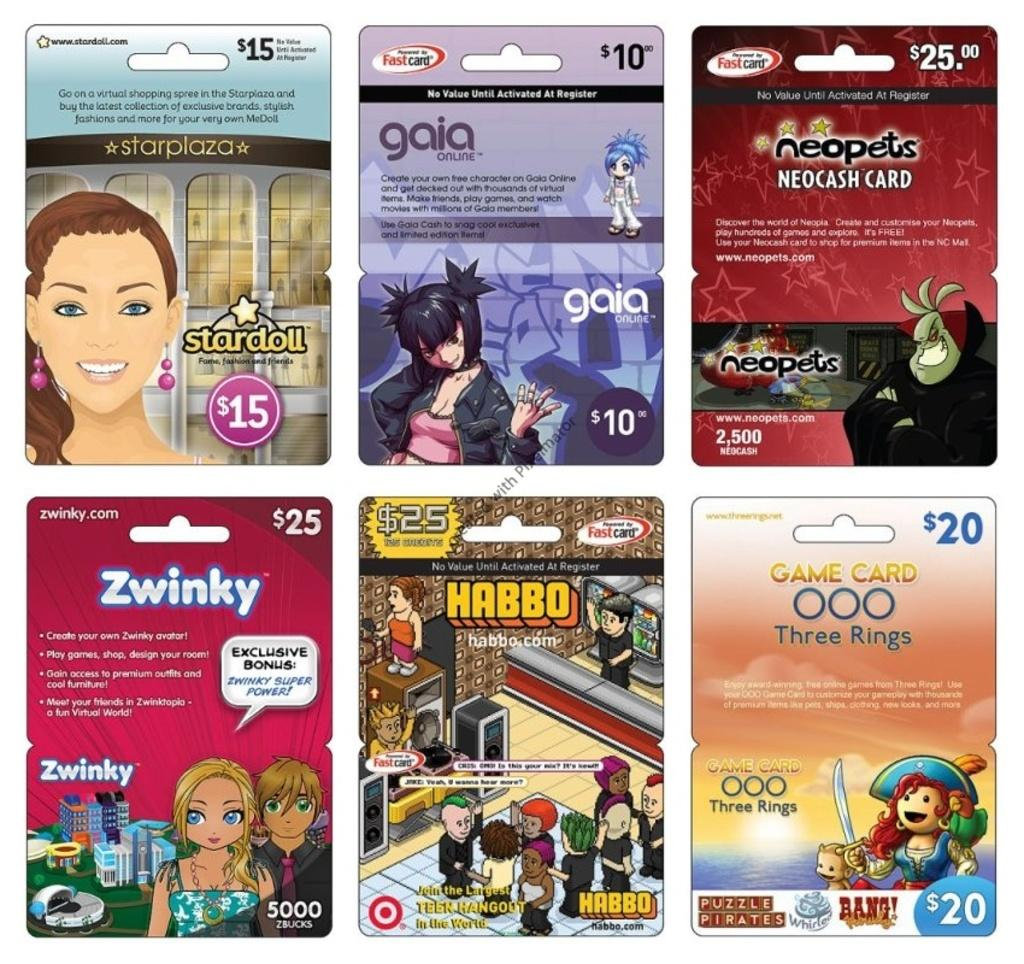How many posters are visible in the foreground of the image? There are six posters in the foreground of the image. What is featured on each poster? Each poster has an image, text, and digits. Can you describe the content of the posters? Unfortunately, the specific content of the posters cannot be determined from the provided facts. Is there a bridge visible in the image? No, there is no bridge present in the image. Can you describe the market scene depicted on one of the posters? There is no information about the content of the posters, so we cannot describe any market scenes. 